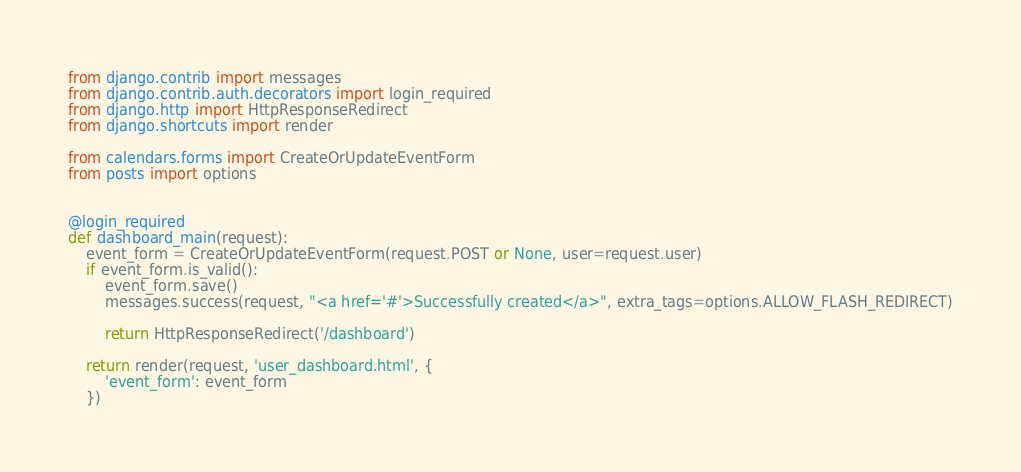Convert code to text. <code><loc_0><loc_0><loc_500><loc_500><_Python_>from django.contrib import messages
from django.contrib.auth.decorators import login_required
from django.http import HttpResponseRedirect
from django.shortcuts import render

from calendars.forms import CreateOrUpdateEventForm
from posts import options


@login_required
def dashboard_main(request):
    event_form = CreateOrUpdateEventForm(request.POST or None, user=request.user)
    if event_form.is_valid():
        event_form.save()
        messages.success(request, "<a href='#'>Successfully created</a>", extra_tags=options.ALLOW_FLASH_REDIRECT)

        return HttpResponseRedirect('/dashboard')

    return render(request, 'user_dashboard.html', {
        'event_form': event_form
    })
</code> 